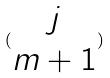Convert formula to latex. <formula><loc_0><loc_0><loc_500><loc_500>( \begin{matrix} j \\ m + 1 \end{matrix} )</formula> 